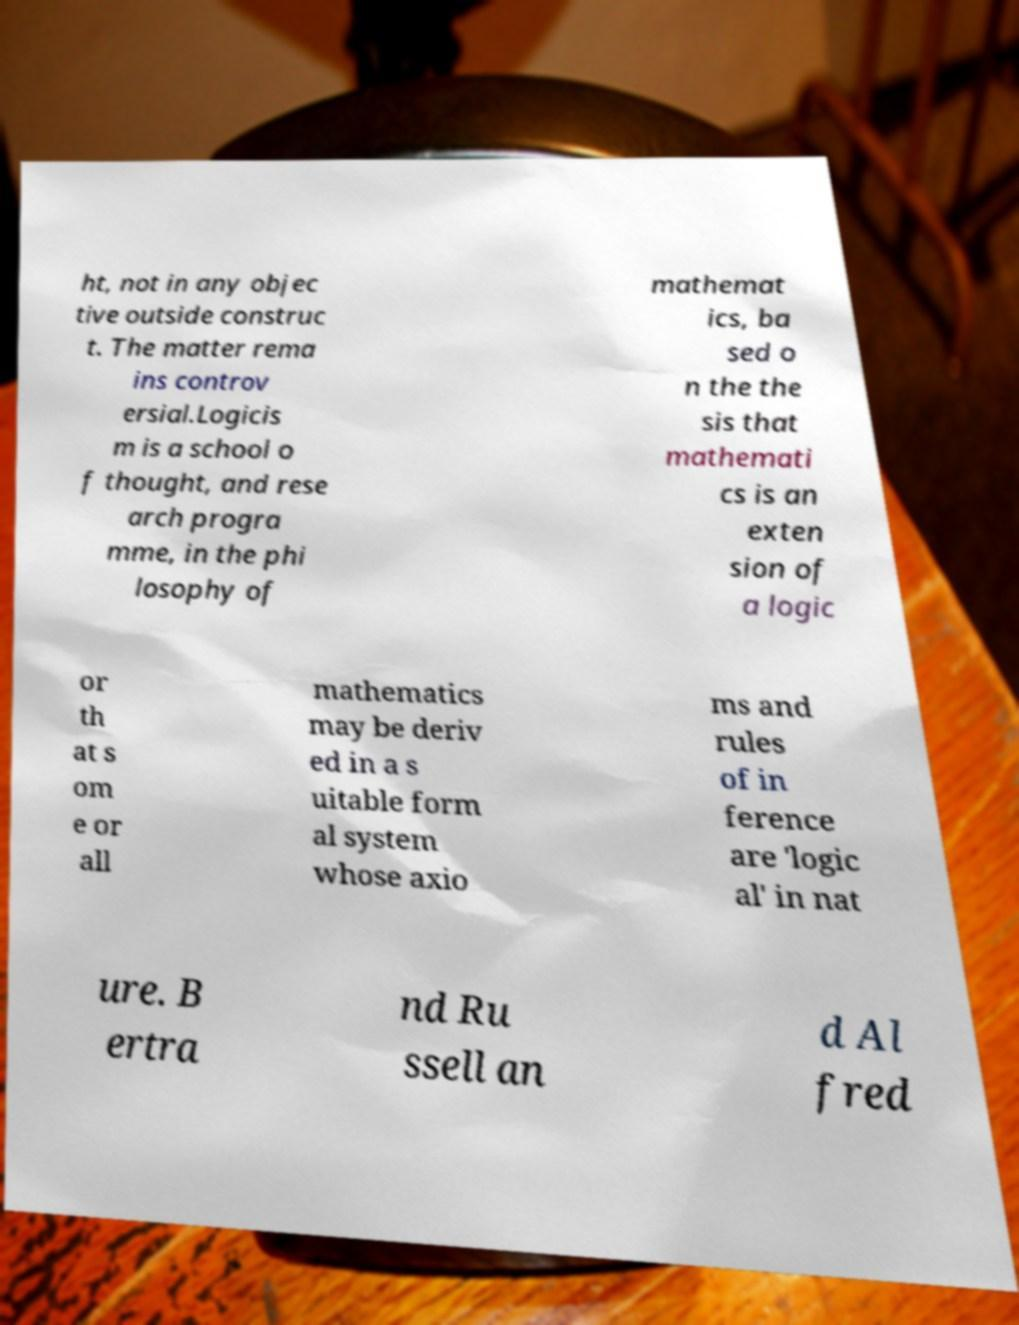Can you read and provide the text displayed in the image?This photo seems to have some interesting text. Can you extract and type it out for me? ht, not in any objec tive outside construc t. The matter rema ins controv ersial.Logicis m is a school o f thought, and rese arch progra mme, in the phi losophy of mathemat ics, ba sed o n the the sis that mathemati cs is an exten sion of a logic or th at s om e or all mathematics may be deriv ed in a s uitable form al system whose axio ms and rules of in ference are 'logic al' in nat ure. B ertra nd Ru ssell an d Al fred 